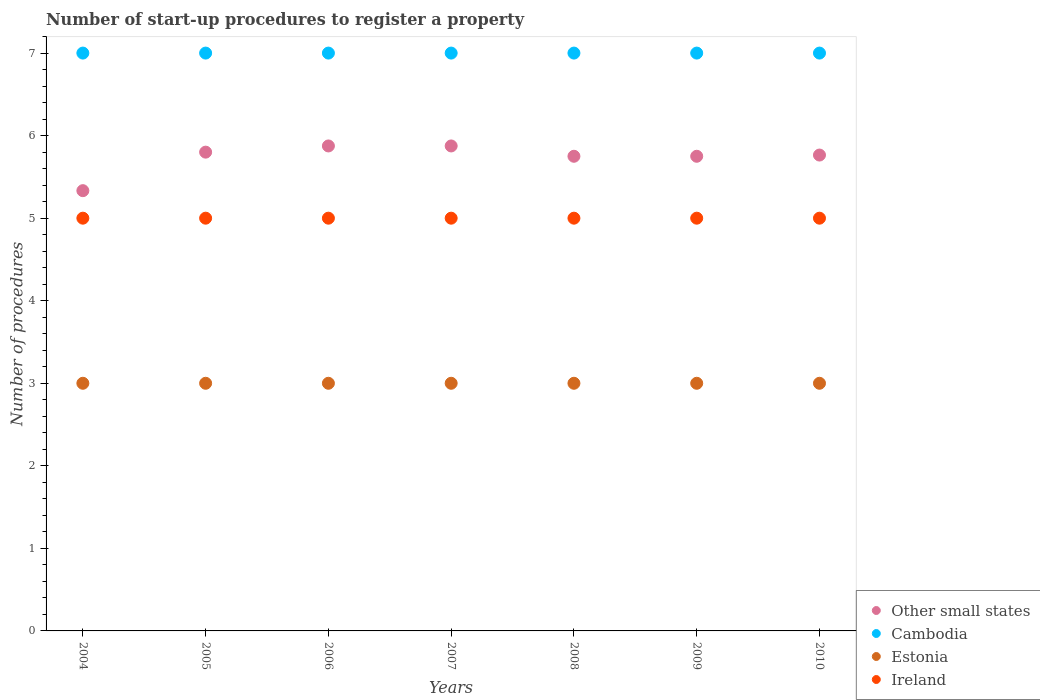How many different coloured dotlines are there?
Ensure brevity in your answer.  4. What is the number of procedures required to register a property in Estonia in 2010?
Provide a succinct answer. 3. Across all years, what is the maximum number of procedures required to register a property in Other small states?
Ensure brevity in your answer.  5.88. Across all years, what is the minimum number of procedures required to register a property in Cambodia?
Your response must be concise. 7. In which year was the number of procedures required to register a property in Other small states maximum?
Provide a succinct answer. 2006. In which year was the number of procedures required to register a property in Cambodia minimum?
Make the answer very short. 2004. What is the total number of procedures required to register a property in Ireland in the graph?
Provide a short and direct response. 35. What is the difference between the number of procedures required to register a property in Estonia in 2004 and that in 2006?
Give a very brief answer. 0. What is the difference between the number of procedures required to register a property in Cambodia in 2005 and the number of procedures required to register a property in Other small states in 2008?
Your response must be concise. 1.25. What is the average number of procedures required to register a property in Cambodia per year?
Your answer should be very brief. 7. In the year 2006, what is the difference between the number of procedures required to register a property in Ireland and number of procedures required to register a property in Cambodia?
Offer a terse response. -2. Is the number of procedures required to register a property in Estonia in 2004 less than that in 2006?
Give a very brief answer. No. Is the difference between the number of procedures required to register a property in Ireland in 2005 and 2006 greater than the difference between the number of procedures required to register a property in Cambodia in 2005 and 2006?
Your answer should be very brief. No. What is the difference between the highest and the lowest number of procedures required to register a property in Cambodia?
Make the answer very short. 0. In how many years, is the number of procedures required to register a property in Cambodia greater than the average number of procedures required to register a property in Cambodia taken over all years?
Offer a terse response. 0. Is the sum of the number of procedures required to register a property in Other small states in 2006 and 2010 greater than the maximum number of procedures required to register a property in Ireland across all years?
Your answer should be compact. Yes. Is it the case that in every year, the sum of the number of procedures required to register a property in Estonia and number of procedures required to register a property in Ireland  is greater than the sum of number of procedures required to register a property in Other small states and number of procedures required to register a property in Cambodia?
Your answer should be very brief. No. Does the number of procedures required to register a property in Other small states monotonically increase over the years?
Keep it short and to the point. No. Is the number of procedures required to register a property in Cambodia strictly less than the number of procedures required to register a property in Ireland over the years?
Give a very brief answer. No. How many dotlines are there?
Make the answer very short. 4. How many years are there in the graph?
Keep it short and to the point. 7. What is the difference between two consecutive major ticks on the Y-axis?
Give a very brief answer. 1. Are the values on the major ticks of Y-axis written in scientific E-notation?
Offer a terse response. No. Does the graph contain grids?
Ensure brevity in your answer.  No. Where does the legend appear in the graph?
Your response must be concise. Bottom right. What is the title of the graph?
Make the answer very short. Number of start-up procedures to register a property. Does "Togo" appear as one of the legend labels in the graph?
Provide a short and direct response. No. What is the label or title of the X-axis?
Your answer should be very brief. Years. What is the label or title of the Y-axis?
Keep it short and to the point. Number of procedures. What is the Number of procedures of Other small states in 2004?
Your answer should be very brief. 5.33. What is the Number of procedures of Cambodia in 2004?
Your response must be concise. 7. What is the Number of procedures of Estonia in 2005?
Ensure brevity in your answer.  3. What is the Number of procedures in Other small states in 2006?
Your answer should be very brief. 5.88. What is the Number of procedures in Estonia in 2006?
Your response must be concise. 3. What is the Number of procedures of Ireland in 2006?
Give a very brief answer. 5. What is the Number of procedures of Other small states in 2007?
Provide a short and direct response. 5.88. What is the Number of procedures of Other small states in 2008?
Provide a succinct answer. 5.75. What is the Number of procedures in Cambodia in 2008?
Ensure brevity in your answer.  7. What is the Number of procedures in Estonia in 2008?
Give a very brief answer. 3. What is the Number of procedures in Other small states in 2009?
Offer a very short reply. 5.75. What is the Number of procedures of Other small states in 2010?
Give a very brief answer. 5.76. What is the Number of procedures in Cambodia in 2010?
Your answer should be compact. 7. What is the Number of procedures in Ireland in 2010?
Offer a terse response. 5. Across all years, what is the maximum Number of procedures of Other small states?
Offer a terse response. 5.88. Across all years, what is the maximum Number of procedures of Cambodia?
Ensure brevity in your answer.  7. Across all years, what is the maximum Number of procedures of Estonia?
Your response must be concise. 3. Across all years, what is the maximum Number of procedures of Ireland?
Keep it short and to the point. 5. Across all years, what is the minimum Number of procedures of Other small states?
Offer a very short reply. 5.33. Across all years, what is the minimum Number of procedures in Estonia?
Your response must be concise. 3. What is the total Number of procedures of Other small states in the graph?
Your answer should be very brief. 40.15. What is the difference between the Number of procedures in Other small states in 2004 and that in 2005?
Make the answer very short. -0.47. What is the difference between the Number of procedures of Cambodia in 2004 and that in 2005?
Offer a very short reply. 0. What is the difference between the Number of procedures of Ireland in 2004 and that in 2005?
Your answer should be very brief. 0. What is the difference between the Number of procedures of Other small states in 2004 and that in 2006?
Your answer should be very brief. -0.54. What is the difference between the Number of procedures in Cambodia in 2004 and that in 2006?
Ensure brevity in your answer.  0. What is the difference between the Number of procedures in Other small states in 2004 and that in 2007?
Provide a succinct answer. -0.54. What is the difference between the Number of procedures of Cambodia in 2004 and that in 2007?
Offer a terse response. 0. What is the difference between the Number of procedures in Estonia in 2004 and that in 2007?
Your response must be concise. 0. What is the difference between the Number of procedures in Other small states in 2004 and that in 2008?
Offer a terse response. -0.42. What is the difference between the Number of procedures in Ireland in 2004 and that in 2008?
Provide a short and direct response. 0. What is the difference between the Number of procedures of Other small states in 2004 and that in 2009?
Offer a terse response. -0.42. What is the difference between the Number of procedures in Cambodia in 2004 and that in 2009?
Offer a terse response. 0. What is the difference between the Number of procedures in Ireland in 2004 and that in 2009?
Give a very brief answer. 0. What is the difference between the Number of procedures in Other small states in 2004 and that in 2010?
Keep it short and to the point. -0.43. What is the difference between the Number of procedures of Other small states in 2005 and that in 2006?
Keep it short and to the point. -0.07. What is the difference between the Number of procedures of Cambodia in 2005 and that in 2006?
Your answer should be compact. 0. What is the difference between the Number of procedures in Ireland in 2005 and that in 2006?
Your answer should be very brief. 0. What is the difference between the Number of procedures in Other small states in 2005 and that in 2007?
Ensure brevity in your answer.  -0.07. What is the difference between the Number of procedures of Cambodia in 2005 and that in 2007?
Provide a succinct answer. 0. What is the difference between the Number of procedures of Estonia in 2005 and that in 2008?
Your response must be concise. 0. What is the difference between the Number of procedures of Ireland in 2005 and that in 2008?
Provide a succinct answer. 0. What is the difference between the Number of procedures in Other small states in 2005 and that in 2009?
Give a very brief answer. 0.05. What is the difference between the Number of procedures in Estonia in 2005 and that in 2009?
Your response must be concise. 0. What is the difference between the Number of procedures in Other small states in 2005 and that in 2010?
Provide a short and direct response. 0.04. What is the difference between the Number of procedures of Cambodia in 2005 and that in 2010?
Give a very brief answer. 0. What is the difference between the Number of procedures in Estonia in 2005 and that in 2010?
Provide a short and direct response. 0. What is the difference between the Number of procedures of Cambodia in 2006 and that in 2007?
Ensure brevity in your answer.  0. What is the difference between the Number of procedures of Estonia in 2006 and that in 2007?
Your answer should be very brief. 0. What is the difference between the Number of procedures of Ireland in 2006 and that in 2007?
Provide a succinct answer. 0. What is the difference between the Number of procedures in Cambodia in 2006 and that in 2008?
Make the answer very short. 0. What is the difference between the Number of procedures in Ireland in 2006 and that in 2008?
Give a very brief answer. 0. What is the difference between the Number of procedures of Other small states in 2006 and that in 2010?
Your answer should be very brief. 0.11. What is the difference between the Number of procedures in Cambodia in 2006 and that in 2010?
Make the answer very short. 0. What is the difference between the Number of procedures of Estonia in 2006 and that in 2010?
Your answer should be very brief. 0. What is the difference between the Number of procedures of Estonia in 2007 and that in 2008?
Provide a succinct answer. 0. What is the difference between the Number of procedures of Ireland in 2007 and that in 2008?
Your answer should be compact. 0. What is the difference between the Number of procedures in Other small states in 2007 and that in 2009?
Your answer should be very brief. 0.12. What is the difference between the Number of procedures in Cambodia in 2007 and that in 2009?
Ensure brevity in your answer.  0. What is the difference between the Number of procedures in Other small states in 2007 and that in 2010?
Your response must be concise. 0.11. What is the difference between the Number of procedures of Estonia in 2007 and that in 2010?
Offer a very short reply. 0. What is the difference between the Number of procedures of Other small states in 2008 and that in 2009?
Keep it short and to the point. 0. What is the difference between the Number of procedures in Cambodia in 2008 and that in 2009?
Ensure brevity in your answer.  0. What is the difference between the Number of procedures in Ireland in 2008 and that in 2009?
Ensure brevity in your answer.  0. What is the difference between the Number of procedures of Other small states in 2008 and that in 2010?
Make the answer very short. -0.01. What is the difference between the Number of procedures of Cambodia in 2008 and that in 2010?
Give a very brief answer. 0. What is the difference between the Number of procedures of Ireland in 2008 and that in 2010?
Give a very brief answer. 0. What is the difference between the Number of procedures of Other small states in 2009 and that in 2010?
Offer a very short reply. -0.01. What is the difference between the Number of procedures in Estonia in 2009 and that in 2010?
Give a very brief answer. 0. What is the difference between the Number of procedures of Other small states in 2004 and the Number of procedures of Cambodia in 2005?
Ensure brevity in your answer.  -1.67. What is the difference between the Number of procedures in Other small states in 2004 and the Number of procedures in Estonia in 2005?
Offer a terse response. 2.33. What is the difference between the Number of procedures in Other small states in 2004 and the Number of procedures in Ireland in 2005?
Your answer should be compact. 0.33. What is the difference between the Number of procedures in Cambodia in 2004 and the Number of procedures in Estonia in 2005?
Provide a succinct answer. 4. What is the difference between the Number of procedures of Cambodia in 2004 and the Number of procedures of Ireland in 2005?
Give a very brief answer. 2. What is the difference between the Number of procedures in Other small states in 2004 and the Number of procedures in Cambodia in 2006?
Your answer should be very brief. -1.67. What is the difference between the Number of procedures of Other small states in 2004 and the Number of procedures of Estonia in 2006?
Provide a short and direct response. 2.33. What is the difference between the Number of procedures of Other small states in 2004 and the Number of procedures of Cambodia in 2007?
Offer a terse response. -1.67. What is the difference between the Number of procedures of Other small states in 2004 and the Number of procedures of Estonia in 2007?
Give a very brief answer. 2.33. What is the difference between the Number of procedures of Cambodia in 2004 and the Number of procedures of Estonia in 2007?
Ensure brevity in your answer.  4. What is the difference between the Number of procedures of Other small states in 2004 and the Number of procedures of Cambodia in 2008?
Make the answer very short. -1.67. What is the difference between the Number of procedures of Other small states in 2004 and the Number of procedures of Estonia in 2008?
Your answer should be compact. 2.33. What is the difference between the Number of procedures of Other small states in 2004 and the Number of procedures of Cambodia in 2009?
Offer a terse response. -1.67. What is the difference between the Number of procedures in Other small states in 2004 and the Number of procedures in Estonia in 2009?
Give a very brief answer. 2.33. What is the difference between the Number of procedures in Other small states in 2004 and the Number of procedures in Ireland in 2009?
Your response must be concise. 0.33. What is the difference between the Number of procedures of Cambodia in 2004 and the Number of procedures of Estonia in 2009?
Keep it short and to the point. 4. What is the difference between the Number of procedures of Cambodia in 2004 and the Number of procedures of Ireland in 2009?
Provide a succinct answer. 2. What is the difference between the Number of procedures of Estonia in 2004 and the Number of procedures of Ireland in 2009?
Ensure brevity in your answer.  -2. What is the difference between the Number of procedures in Other small states in 2004 and the Number of procedures in Cambodia in 2010?
Provide a short and direct response. -1.67. What is the difference between the Number of procedures in Other small states in 2004 and the Number of procedures in Estonia in 2010?
Provide a succinct answer. 2.33. What is the difference between the Number of procedures of Other small states in 2004 and the Number of procedures of Ireland in 2010?
Offer a terse response. 0.33. What is the difference between the Number of procedures in Cambodia in 2004 and the Number of procedures in Estonia in 2010?
Provide a succinct answer. 4. What is the difference between the Number of procedures in Cambodia in 2004 and the Number of procedures in Ireland in 2010?
Keep it short and to the point. 2. What is the difference between the Number of procedures in Other small states in 2005 and the Number of procedures in Cambodia in 2006?
Provide a short and direct response. -1.2. What is the difference between the Number of procedures of Estonia in 2005 and the Number of procedures of Ireland in 2006?
Ensure brevity in your answer.  -2. What is the difference between the Number of procedures in Other small states in 2005 and the Number of procedures in Cambodia in 2007?
Make the answer very short. -1.2. What is the difference between the Number of procedures in Other small states in 2005 and the Number of procedures in Ireland in 2007?
Give a very brief answer. 0.8. What is the difference between the Number of procedures in Cambodia in 2005 and the Number of procedures in Estonia in 2007?
Give a very brief answer. 4. What is the difference between the Number of procedures in Cambodia in 2005 and the Number of procedures in Ireland in 2007?
Make the answer very short. 2. What is the difference between the Number of procedures in Estonia in 2005 and the Number of procedures in Ireland in 2007?
Keep it short and to the point. -2. What is the difference between the Number of procedures in Other small states in 2005 and the Number of procedures in Ireland in 2008?
Make the answer very short. 0.8. What is the difference between the Number of procedures in Other small states in 2005 and the Number of procedures in Estonia in 2009?
Your response must be concise. 2.8. What is the difference between the Number of procedures in Other small states in 2005 and the Number of procedures in Ireland in 2009?
Keep it short and to the point. 0.8. What is the difference between the Number of procedures of Cambodia in 2005 and the Number of procedures of Estonia in 2009?
Offer a terse response. 4. What is the difference between the Number of procedures of Cambodia in 2005 and the Number of procedures of Ireland in 2009?
Your answer should be compact. 2. What is the difference between the Number of procedures in Other small states in 2005 and the Number of procedures in Estonia in 2010?
Your response must be concise. 2.8. What is the difference between the Number of procedures of Other small states in 2005 and the Number of procedures of Ireland in 2010?
Your answer should be compact. 0.8. What is the difference between the Number of procedures in Cambodia in 2005 and the Number of procedures in Ireland in 2010?
Offer a terse response. 2. What is the difference between the Number of procedures in Estonia in 2005 and the Number of procedures in Ireland in 2010?
Keep it short and to the point. -2. What is the difference between the Number of procedures in Other small states in 2006 and the Number of procedures in Cambodia in 2007?
Provide a succinct answer. -1.12. What is the difference between the Number of procedures in Other small states in 2006 and the Number of procedures in Estonia in 2007?
Provide a succinct answer. 2.88. What is the difference between the Number of procedures in Cambodia in 2006 and the Number of procedures in Ireland in 2007?
Give a very brief answer. 2. What is the difference between the Number of procedures of Estonia in 2006 and the Number of procedures of Ireland in 2007?
Make the answer very short. -2. What is the difference between the Number of procedures in Other small states in 2006 and the Number of procedures in Cambodia in 2008?
Your answer should be very brief. -1.12. What is the difference between the Number of procedures in Other small states in 2006 and the Number of procedures in Estonia in 2008?
Your answer should be compact. 2.88. What is the difference between the Number of procedures of Other small states in 2006 and the Number of procedures of Cambodia in 2009?
Offer a very short reply. -1.12. What is the difference between the Number of procedures of Other small states in 2006 and the Number of procedures of Estonia in 2009?
Give a very brief answer. 2.88. What is the difference between the Number of procedures of Estonia in 2006 and the Number of procedures of Ireland in 2009?
Your answer should be very brief. -2. What is the difference between the Number of procedures in Other small states in 2006 and the Number of procedures in Cambodia in 2010?
Provide a succinct answer. -1.12. What is the difference between the Number of procedures of Other small states in 2006 and the Number of procedures of Estonia in 2010?
Your response must be concise. 2.88. What is the difference between the Number of procedures of Other small states in 2006 and the Number of procedures of Ireland in 2010?
Provide a succinct answer. 0.88. What is the difference between the Number of procedures in Cambodia in 2006 and the Number of procedures in Estonia in 2010?
Offer a terse response. 4. What is the difference between the Number of procedures of Cambodia in 2006 and the Number of procedures of Ireland in 2010?
Keep it short and to the point. 2. What is the difference between the Number of procedures in Other small states in 2007 and the Number of procedures in Cambodia in 2008?
Your answer should be very brief. -1.12. What is the difference between the Number of procedures of Other small states in 2007 and the Number of procedures of Estonia in 2008?
Offer a very short reply. 2.88. What is the difference between the Number of procedures of Other small states in 2007 and the Number of procedures of Ireland in 2008?
Provide a succinct answer. 0.88. What is the difference between the Number of procedures in Cambodia in 2007 and the Number of procedures in Estonia in 2008?
Your answer should be very brief. 4. What is the difference between the Number of procedures in Cambodia in 2007 and the Number of procedures in Ireland in 2008?
Your answer should be very brief. 2. What is the difference between the Number of procedures in Estonia in 2007 and the Number of procedures in Ireland in 2008?
Give a very brief answer. -2. What is the difference between the Number of procedures in Other small states in 2007 and the Number of procedures in Cambodia in 2009?
Offer a very short reply. -1.12. What is the difference between the Number of procedures in Other small states in 2007 and the Number of procedures in Estonia in 2009?
Offer a very short reply. 2.88. What is the difference between the Number of procedures in Other small states in 2007 and the Number of procedures in Ireland in 2009?
Offer a terse response. 0.88. What is the difference between the Number of procedures in Cambodia in 2007 and the Number of procedures in Estonia in 2009?
Your response must be concise. 4. What is the difference between the Number of procedures in Cambodia in 2007 and the Number of procedures in Ireland in 2009?
Your answer should be very brief. 2. What is the difference between the Number of procedures of Estonia in 2007 and the Number of procedures of Ireland in 2009?
Your response must be concise. -2. What is the difference between the Number of procedures in Other small states in 2007 and the Number of procedures in Cambodia in 2010?
Offer a very short reply. -1.12. What is the difference between the Number of procedures of Other small states in 2007 and the Number of procedures of Estonia in 2010?
Make the answer very short. 2.88. What is the difference between the Number of procedures in Cambodia in 2007 and the Number of procedures in Estonia in 2010?
Your answer should be very brief. 4. What is the difference between the Number of procedures of Other small states in 2008 and the Number of procedures of Cambodia in 2009?
Ensure brevity in your answer.  -1.25. What is the difference between the Number of procedures in Other small states in 2008 and the Number of procedures in Estonia in 2009?
Provide a short and direct response. 2.75. What is the difference between the Number of procedures in Other small states in 2008 and the Number of procedures in Ireland in 2009?
Your response must be concise. 0.75. What is the difference between the Number of procedures in Other small states in 2008 and the Number of procedures in Cambodia in 2010?
Offer a terse response. -1.25. What is the difference between the Number of procedures in Other small states in 2008 and the Number of procedures in Estonia in 2010?
Make the answer very short. 2.75. What is the difference between the Number of procedures in Other small states in 2008 and the Number of procedures in Ireland in 2010?
Offer a terse response. 0.75. What is the difference between the Number of procedures of Other small states in 2009 and the Number of procedures of Cambodia in 2010?
Keep it short and to the point. -1.25. What is the difference between the Number of procedures of Other small states in 2009 and the Number of procedures of Estonia in 2010?
Make the answer very short. 2.75. What is the difference between the Number of procedures of Cambodia in 2009 and the Number of procedures of Estonia in 2010?
Your answer should be very brief. 4. What is the difference between the Number of procedures in Estonia in 2009 and the Number of procedures in Ireland in 2010?
Your response must be concise. -2. What is the average Number of procedures in Other small states per year?
Your answer should be compact. 5.74. What is the average Number of procedures in Estonia per year?
Give a very brief answer. 3. What is the average Number of procedures of Ireland per year?
Keep it short and to the point. 5. In the year 2004, what is the difference between the Number of procedures in Other small states and Number of procedures in Cambodia?
Provide a succinct answer. -1.67. In the year 2004, what is the difference between the Number of procedures in Other small states and Number of procedures in Estonia?
Give a very brief answer. 2.33. In the year 2004, what is the difference between the Number of procedures of Other small states and Number of procedures of Ireland?
Your response must be concise. 0.33. In the year 2004, what is the difference between the Number of procedures in Cambodia and Number of procedures in Ireland?
Offer a terse response. 2. In the year 2005, what is the difference between the Number of procedures in Other small states and Number of procedures in Cambodia?
Offer a very short reply. -1.2. In the year 2005, what is the difference between the Number of procedures in Other small states and Number of procedures in Estonia?
Keep it short and to the point. 2.8. In the year 2005, what is the difference between the Number of procedures in Cambodia and Number of procedures in Ireland?
Offer a very short reply. 2. In the year 2005, what is the difference between the Number of procedures in Estonia and Number of procedures in Ireland?
Provide a short and direct response. -2. In the year 2006, what is the difference between the Number of procedures of Other small states and Number of procedures of Cambodia?
Keep it short and to the point. -1.12. In the year 2006, what is the difference between the Number of procedures of Other small states and Number of procedures of Estonia?
Give a very brief answer. 2.88. In the year 2006, what is the difference between the Number of procedures in Other small states and Number of procedures in Ireland?
Provide a short and direct response. 0.88. In the year 2006, what is the difference between the Number of procedures of Cambodia and Number of procedures of Estonia?
Offer a terse response. 4. In the year 2007, what is the difference between the Number of procedures of Other small states and Number of procedures of Cambodia?
Your answer should be compact. -1.12. In the year 2007, what is the difference between the Number of procedures of Other small states and Number of procedures of Estonia?
Offer a very short reply. 2.88. In the year 2007, what is the difference between the Number of procedures of Other small states and Number of procedures of Ireland?
Make the answer very short. 0.88. In the year 2007, what is the difference between the Number of procedures in Cambodia and Number of procedures in Estonia?
Your answer should be very brief. 4. In the year 2007, what is the difference between the Number of procedures of Cambodia and Number of procedures of Ireland?
Offer a very short reply. 2. In the year 2008, what is the difference between the Number of procedures of Other small states and Number of procedures of Cambodia?
Your response must be concise. -1.25. In the year 2008, what is the difference between the Number of procedures of Other small states and Number of procedures of Estonia?
Offer a very short reply. 2.75. In the year 2008, what is the difference between the Number of procedures of Other small states and Number of procedures of Ireland?
Offer a very short reply. 0.75. In the year 2008, what is the difference between the Number of procedures of Cambodia and Number of procedures of Estonia?
Keep it short and to the point. 4. In the year 2008, what is the difference between the Number of procedures of Estonia and Number of procedures of Ireland?
Your answer should be very brief. -2. In the year 2009, what is the difference between the Number of procedures in Other small states and Number of procedures in Cambodia?
Make the answer very short. -1.25. In the year 2009, what is the difference between the Number of procedures in Other small states and Number of procedures in Estonia?
Make the answer very short. 2.75. In the year 2010, what is the difference between the Number of procedures in Other small states and Number of procedures in Cambodia?
Make the answer very short. -1.24. In the year 2010, what is the difference between the Number of procedures in Other small states and Number of procedures in Estonia?
Provide a short and direct response. 2.76. In the year 2010, what is the difference between the Number of procedures in Other small states and Number of procedures in Ireland?
Ensure brevity in your answer.  0.76. In the year 2010, what is the difference between the Number of procedures of Cambodia and Number of procedures of Estonia?
Your response must be concise. 4. In the year 2010, what is the difference between the Number of procedures of Estonia and Number of procedures of Ireland?
Ensure brevity in your answer.  -2. What is the ratio of the Number of procedures in Other small states in 2004 to that in 2005?
Your response must be concise. 0.92. What is the ratio of the Number of procedures in Cambodia in 2004 to that in 2005?
Your response must be concise. 1. What is the ratio of the Number of procedures in Estonia in 2004 to that in 2005?
Keep it short and to the point. 1. What is the ratio of the Number of procedures in Ireland in 2004 to that in 2005?
Your response must be concise. 1. What is the ratio of the Number of procedures in Other small states in 2004 to that in 2006?
Provide a succinct answer. 0.91. What is the ratio of the Number of procedures of Cambodia in 2004 to that in 2006?
Make the answer very short. 1. What is the ratio of the Number of procedures in Estonia in 2004 to that in 2006?
Your answer should be compact. 1. What is the ratio of the Number of procedures in Ireland in 2004 to that in 2006?
Keep it short and to the point. 1. What is the ratio of the Number of procedures in Other small states in 2004 to that in 2007?
Your response must be concise. 0.91. What is the ratio of the Number of procedures of Cambodia in 2004 to that in 2007?
Give a very brief answer. 1. What is the ratio of the Number of procedures of Other small states in 2004 to that in 2008?
Make the answer very short. 0.93. What is the ratio of the Number of procedures in Other small states in 2004 to that in 2009?
Provide a succinct answer. 0.93. What is the ratio of the Number of procedures in Cambodia in 2004 to that in 2009?
Provide a succinct answer. 1. What is the ratio of the Number of procedures in Ireland in 2004 to that in 2009?
Your response must be concise. 1. What is the ratio of the Number of procedures of Other small states in 2004 to that in 2010?
Provide a short and direct response. 0.93. What is the ratio of the Number of procedures in Other small states in 2005 to that in 2006?
Offer a terse response. 0.99. What is the ratio of the Number of procedures in Cambodia in 2005 to that in 2006?
Give a very brief answer. 1. What is the ratio of the Number of procedures of Ireland in 2005 to that in 2006?
Your answer should be very brief. 1. What is the ratio of the Number of procedures of Other small states in 2005 to that in 2007?
Your answer should be very brief. 0.99. What is the ratio of the Number of procedures of Estonia in 2005 to that in 2007?
Provide a short and direct response. 1. What is the ratio of the Number of procedures of Other small states in 2005 to that in 2008?
Keep it short and to the point. 1.01. What is the ratio of the Number of procedures of Estonia in 2005 to that in 2008?
Offer a very short reply. 1. What is the ratio of the Number of procedures in Ireland in 2005 to that in 2008?
Your response must be concise. 1. What is the ratio of the Number of procedures of Other small states in 2005 to that in 2009?
Your answer should be compact. 1.01. What is the ratio of the Number of procedures of Cambodia in 2005 to that in 2009?
Provide a short and direct response. 1. What is the ratio of the Number of procedures of Estonia in 2005 to that in 2009?
Your answer should be very brief. 1. What is the ratio of the Number of procedures of Ireland in 2005 to that in 2009?
Provide a succinct answer. 1. What is the ratio of the Number of procedures in Other small states in 2005 to that in 2010?
Provide a short and direct response. 1.01. What is the ratio of the Number of procedures of Cambodia in 2005 to that in 2010?
Your response must be concise. 1. What is the ratio of the Number of procedures in Ireland in 2005 to that in 2010?
Offer a terse response. 1. What is the ratio of the Number of procedures of Other small states in 2006 to that in 2007?
Your response must be concise. 1. What is the ratio of the Number of procedures in Cambodia in 2006 to that in 2007?
Provide a succinct answer. 1. What is the ratio of the Number of procedures of Ireland in 2006 to that in 2007?
Give a very brief answer. 1. What is the ratio of the Number of procedures of Other small states in 2006 to that in 2008?
Ensure brevity in your answer.  1.02. What is the ratio of the Number of procedures in Other small states in 2006 to that in 2009?
Offer a terse response. 1.02. What is the ratio of the Number of procedures in Estonia in 2006 to that in 2009?
Offer a terse response. 1. What is the ratio of the Number of procedures in Other small states in 2006 to that in 2010?
Keep it short and to the point. 1.02. What is the ratio of the Number of procedures in Cambodia in 2006 to that in 2010?
Your answer should be compact. 1. What is the ratio of the Number of procedures in Estonia in 2006 to that in 2010?
Offer a very short reply. 1. What is the ratio of the Number of procedures in Ireland in 2006 to that in 2010?
Offer a very short reply. 1. What is the ratio of the Number of procedures of Other small states in 2007 to that in 2008?
Provide a short and direct response. 1.02. What is the ratio of the Number of procedures in Ireland in 2007 to that in 2008?
Offer a terse response. 1. What is the ratio of the Number of procedures in Other small states in 2007 to that in 2009?
Make the answer very short. 1.02. What is the ratio of the Number of procedures of Estonia in 2007 to that in 2009?
Give a very brief answer. 1. What is the ratio of the Number of procedures in Other small states in 2007 to that in 2010?
Your answer should be compact. 1.02. What is the ratio of the Number of procedures in Ireland in 2007 to that in 2010?
Provide a succinct answer. 1. What is the ratio of the Number of procedures of Other small states in 2008 to that in 2009?
Offer a very short reply. 1. What is the ratio of the Number of procedures in Estonia in 2008 to that in 2009?
Make the answer very short. 1. What is the ratio of the Number of procedures of Ireland in 2008 to that in 2009?
Keep it short and to the point. 1. What is the ratio of the Number of procedures in Other small states in 2008 to that in 2010?
Your response must be concise. 1. What is the ratio of the Number of procedures in Cambodia in 2008 to that in 2010?
Offer a very short reply. 1. What is the ratio of the Number of procedures in Ireland in 2008 to that in 2010?
Ensure brevity in your answer.  1. What is the ratio of the Number of procedures in Ireland in 2009 to that in 2010?
Give a very brief answer. 1. What is the difference between the highest and the second highest Number of procedures of Estonia?
Keep it short and to the point. 0. What is the difference between the highest and the second highest Number of procedures in Ireland?
Provide a short and direct response. 0. What is the difference between the highest and the lowest Number of procedures in Other small states?
Your response must be concise. 0.54. What is the difference between the highest and the lowest Number of procedures of Cambodia?
Your answer should be compact. 0. What is the difference between the highest and the lowest Number of procedures of Ireland?
Your answer should be very brief. 0. 